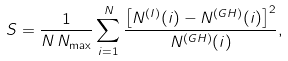Convert formula to latex. <formula><loc_0><loc_0><loc_500><loc_500>S = \frac { 1 } { N \, N _ { \max } } \sum _ { i = 1 } ^ { N } \frac { \left [ N ^ { ( I ) } ( i ) - N ^ { ( G H ) } ( i ) \right ] ^ { 2 } } { N ^ { ( G H ) } ( i ) } ,</formula> 